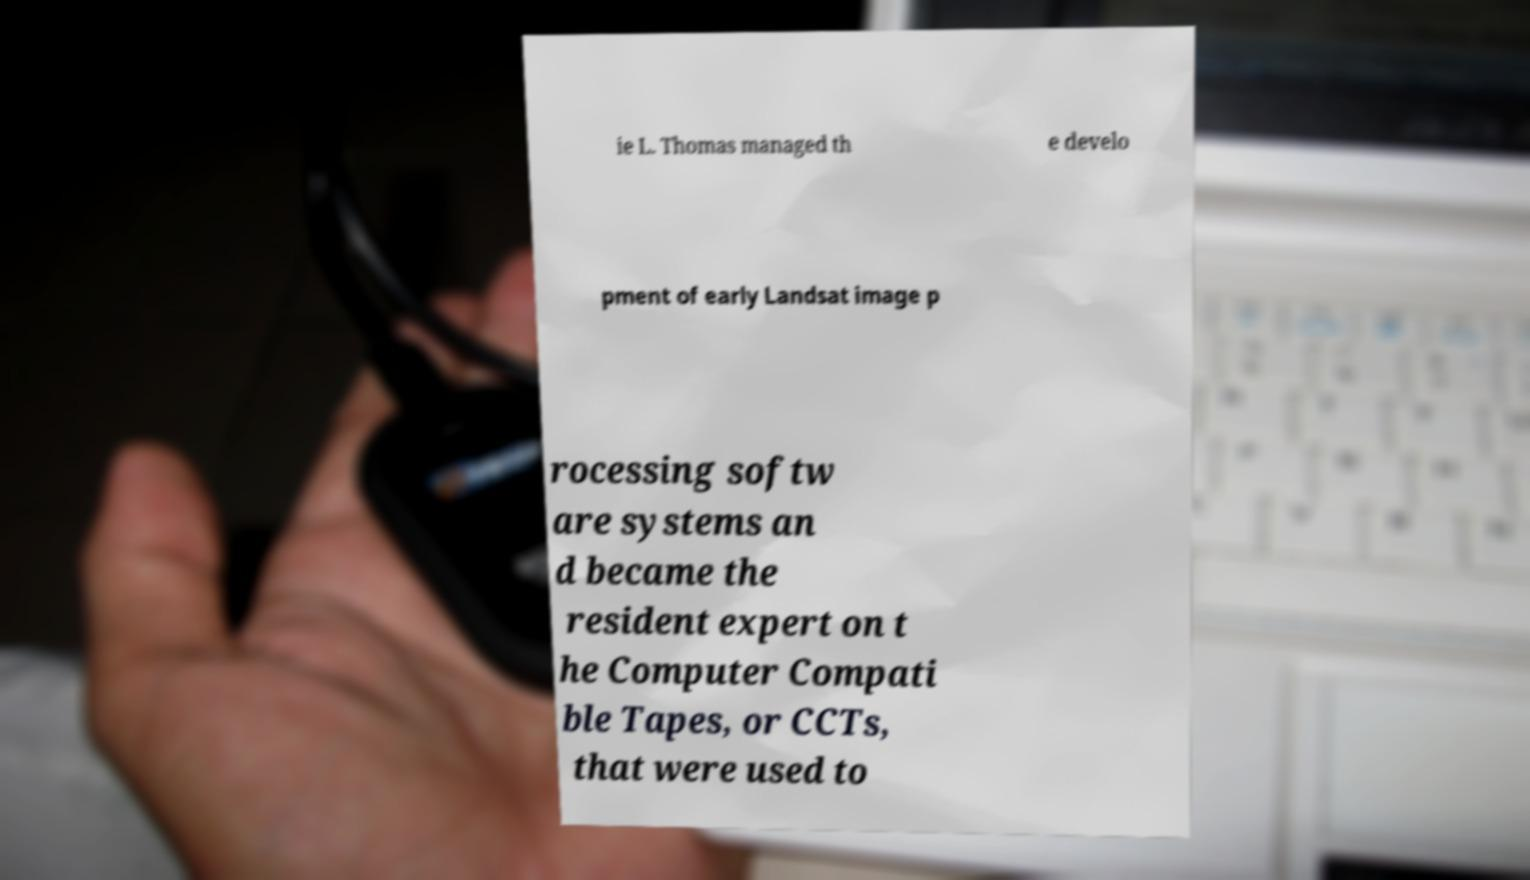For documentation purposes, I need the text within this image transcribed. Could you provide that? ie L. Thomas managed th e develo pment of early Landsat image p rocessing softw are systems an d became the resident expert on t he Computer Compati ble Tapes, or CCTs, that were used to 